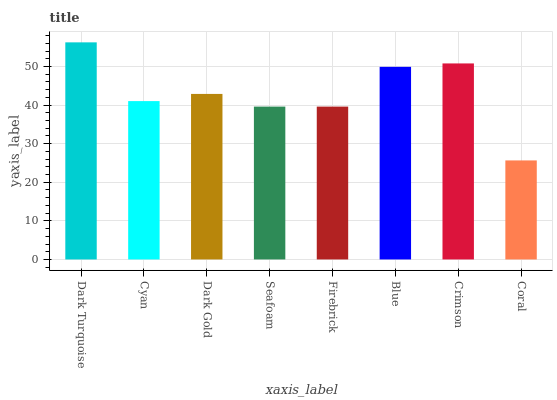Is Coral the minimum?
Answer yes or no. Yes. Is Dark Turquoise the maximum?
Answer yes or no. Yes. Is Cyan the minimum?
Answer yes or no. No. Is Cyan the maximum?
Answer yes or no. No. Is Dark Turquoise greater than Cyan?
Answer yes or no. Yes. Is Cyan less than Dark Turquoise?
Answer yes or no. Yes. Is Cyan greater than Dark Turquoise?
Answer yes or no. No. Is Dark Turquoise less than Cyan?
Answer yes or no. No. Is Dark Gold the high median?
Answer yes or no. Yes. Is Cyan the low median?
Answer yes or no. Yes. Is Crimson the high median?
Answer yes or no. No. Is Dark Gold the low median?
Answer yes or no. No. 